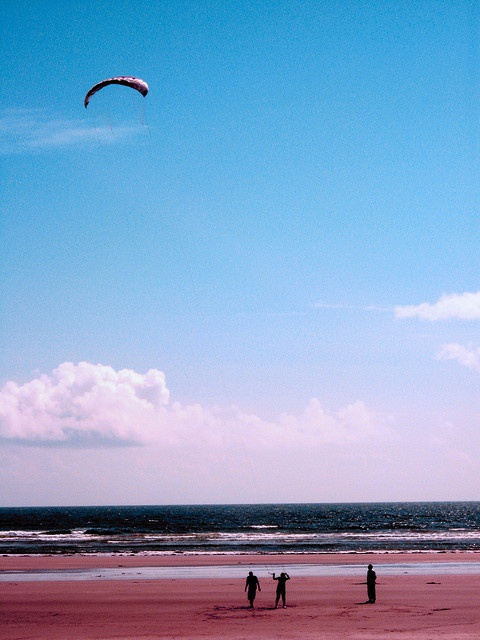Describe the objects in this image and their specific colors. I can see kite in teal, black, lavender, violet, and purple tones, people in teal, black, purple, brown, and gray tones, people in teal, black, purple, and gray tones, and people in teal, black, purple, and maroon tones in this image. 